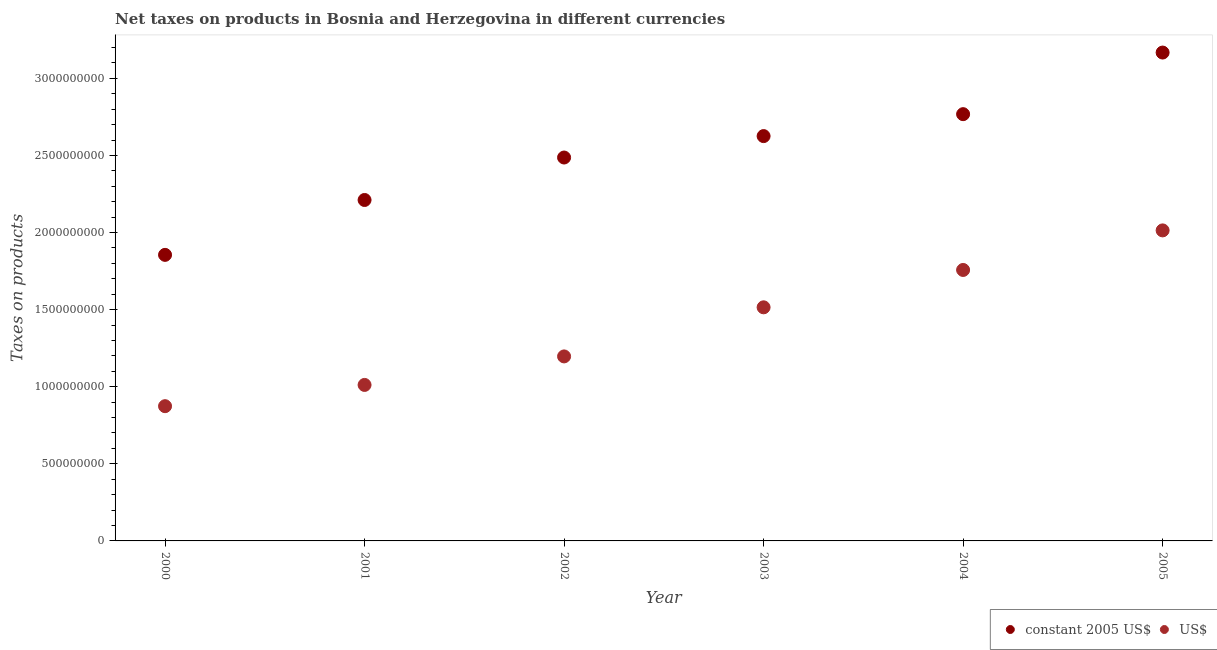What is the net taxes in us$ in 2003?
Make the answer very short. 1.51e+09. Across all years, what is the maximum net taxes in constant 2005 us$?
Offer a terse response. 3.17e+09. Across all years, what is the minimum net taxes in us$?
Keep it short and to the point. 8.74e+08. What is the total net taxes in constant 2005 us$ in the graph?
Your answer should be very brief. 1.51e+1. What is the difference between the net taxes in constant 2005 us$ in 2000 and that in 2001?
Provide a succinct answer. -3.56e+08. What is the difference between the net taxes in us$ in 2004 and the net taxes in constant 2005 us$ in 2005?
Offer a terse response. -1.41e+09. What is the average net taxes in us$ per year?
Ensure brevity in your answer.  1.39e+09. In the year 2005, what is the difference between the net taxes in constant 2005 us$ and net taxes in us$?
Your answer should be very brief. 1.15e+09. In how many years, is the net taxes in constant 2005 us$ greater than 1400000000 units?
Keep it short and to the point. 6. What is the ratio of the net taxes in us$ in 2000 to that in 2005?
Offer a terse response. 0.43. Is the net taxes in constant 2005 us$ in 2000 less than that in 2003?
Ensure brevity in your answer.  Yes. What is the difference between the highest and the second highest net taxes in us$?
Make the answer very short. 2.57e+08. What is the difference between the highest and the lowest net taxes in constant 2005 us$?
Your answer should be very brief. 1.31e+09. How many years are there in the graph?
Ensure brevity in your answer.  6. Are the values on the major ticks of Y-axis written in scientific E-notation?
Ensure brevity in your answer.  No. Does the graph contain grids?
Offer a very short reply. No. How are the legend labels stacked?
Your answer should be very brief. Horizontal. What is the title of the graph?
Ensure brevity in your answer.  Net taxes on products in Bosnia and Herzegovina in different currencies. What is the label or title of the Y-axis?
Make the answer very short. Taxes on products. What is the Taxes on products in constant 2005 US$ in 2000?
Make the answer very short. 1.86e+09. What is the Taxes on products of US$ in 2000?
Your answer should be very brief. 8.74e+08. What is the Taxes on products in constant 2005 US$ in 2001?
Make the answer very short. 2.21e+09. What is the Taxes on products in US$ in 2001?
Offer a very short reply. 1.01e+09. What is the Taxes on products of constant 2005 US$ in 2002?
Keep it short and to the point. 2.49e+09. What is the Taxes on products in US$ in 2002?
Make the answer very short. 1.20e+09. What is the Taxes on products in constant 2005 US$ in 2003?
Ensure brevity in your answer.  2.63e+09. What is the Taxes on products of US$ in 2003?
Offer a terse response. 1.51e+09. What is the Taxes on products in constant 2005 US$ in 2004?
Give a very brief answer. 2.77e+09. What is the Taxes on products of US$ in 2004?
Your answer should be compact. 1.76e+09. What is the Taxes on products of constant 2005 US$ in 2005?
Keep it short and to the point. 3.17e+09. What is the Taxes on products in US$ in 2005?
Your response must be concise. 2.01e+09. Across all years, what is the maximum Taxes on products in constant 2005 US$?
Provide a succinct answer. 3.17e+09. Across all years, what is the maximum Taxes on products in US$?
Offer a very short reply. 2.01e+09. Across all years, what is the minimum Taxes on products in constant 2005 US$?
Offer a terse response. 1.86e+09. Across all years, what is the minimum Taxes on products of US$?
Ensure brevity in your answer.  8.74e+08. What is the total Taxes on products of constant 2005 US$ in the graph?
Give a very brief answer. 1.51e+1. What is the total Taxes on products of US$ in the graph?
Provide a short and direct response. 8.37e+09. What is the difference between the Taxes on products of constant 2005 US$ in 2000 and that in 2001?
Make the answer very short. -3.56e+08. What is the difference between the Taxes on products in US$ in 2000 and that in 2001?
Offer a very short reply. -1.38e+08. What is the difference between the Taxes on products of constant 2005 US$ in 2000 and that in 2002?
Your answer should be compact. -6.31e+08. What is the difference between the Taxes on products in US$ in 2000 and that in 2002?
Your answer should be compact. -3.23e+08. What is the difference between the Taxes on products of constant 2005 US$ in 2000 and that in 2003?
Keep it short and to the point. -7.70e+08. What is the difference between the Taxes on products of US$ in 2000 and that in 2003?
Ensure brevity in your answer.  -6.41e+08. What is the difference between the Taxes on products in constant 2005 US$ in 2000 and that in 2004?
Offer a very short reply. -9.12e+08. What is the difference between the Taxes on products in US$ in 2000 and that in 2004?
Keep it short and to the point. -8.83e+08. What is the difference between the Taxes on products of constant 2005 US$ in 2000 and that in 2005?
Offer a terse response. -1.31e+09. What is the difference between the Taxes on products in US$ in 2000 and that in 2005?
Provide a succinct answer. -1.14e+09. What is the difference between the Taxes on products in constant 2005 US$ in 2001 and that in 2002?
Provide a short and direct response. -2.75e+08. What is the difference between the Taxes on products in US$ in 2001 and that in 2002?
Make the answer very short. -1.85e+08. What is the difference between the Taxes on products of constant 2005 US$ in 2001 and that in 2003?
Your answer should be very brief. -4.14e+08. What is the difference between the Taxes on products of US$ in 2001 and that in 2003?
Make the answer very short. -5.03e+08. What is the difference between the Taxes on products in constant 2005 US$ in 2001 and that in 2004?
Your response must be concise. -5.57e+08. What is the difference between the Taxes on products of US$ in 2001 and that in 2004?
Your answer should be compact. -7.46e+08. What is the difference between the Taxes on products in constant 2005 US$ in 2001 and that in 2005?
Ensure brevity in your answer.  -9.56e+08. What is the difference between the Taxes on products in US$ in 2001 and that in 2005?
Your answer should be compact. -1.00e+09. What is the difference between the Taxes on products of constant 2005 US$ in 2002 and that in 2003?
Offer a terse response. -1.39e+08. What is the difference between the Taxes on products in US$ in 2002 and that in 2003?
Provide a short and direct response. -3.18e+08. What is the difference between the Taxes on products in constant 2005 US$ in 2002 and that in 2004?
Provide a succinct answer. -2.81e+08. What is the difference between the Taxes on products of US$ in 2002 and that in 2004?
Your response must be concise. -5.61e+08. What is the difference between the Taxes on products of constant 2005 US$ in 2002 and that in 2005?
Provide a short and direct response. -6.81e+08. What is the difference between the Taxes on products in US$ in 2002 and that in 2005?
Your response must be concise. -8.17e+08. What is the difference between the Taxes on products in constant 2005 US$ in 2003 and that in 2004?
Your answer should be compact. -1.42e+08. What is the difference between the Taxes on products in US$ in 2003 and that in 2004?
Provide a succinct answer. -2.42e+08. What is the difference between the Taxes on products of constant 2005 US$ in 2003 and that in 2005?
Provide a short and direct response. -5.42e+08. What is the difference between the Taxes on products of US$ in 2003 and that in 2005?
Provide a succinct answer. -4.99e+08. What is the difference between the Taxes on products of constant 2005 US$ in 2004 and that in 2005?
Your response must be concise. -4.00e+08. What is the difference between the Taxes on products in US$ in 2004 and that in 2005?
Your response must be concise. -2.57e+08. What is the difference between the Taxes on products of constant 2005 US$ in 2000 and the Taxes on products of US$ in 2001?
Your response must be concise. 8.43e+08. What is the difference between the Taxes on products in constant 2005 US$ in 2000 and the Taxes on products in US$ in 2002?
Keep it short and to the point. 6.59e+08. What is the difference between the Taxes on products of constant 2005 US$ in 2000 and the Taxes on products of US$ in 2003?
Provide a short and direct response. 3.40e+08. What is the difference between the Taxes on products in constant 2005 US$ in 2000 and the Taxes on products in US$ in 2004?
Keep it short and to the point. 9.79e+07. What is the difference between the Taxes on products of constant 2005 US$ in 2000 and the Taxes on products of US$ in 2005?
Make the answer very short. -1.59e+08. What is the difference between the Taxes on products of constant 2005 US$ in 2001 and the Taxes on products of US$ in 2002?
Offer a very short reply. 1.01e+09. What is the difference between the Taxes on products in constant 2005 US$ in 2001 and the Taxes on products in US$ in 2003?
Your response must be concise. 6.96e+08. What is the difference between the Taxes on products of constant 2005 US$ in 2001 and the Taxes on products of US$ in 2004?
Ensure brevity in your answer.  4.54e+08. What is the difference between the Taxes on products in constant 2005 US$ in 2001 and the Taxes on products in US$ in 2005?
Offer a very short reply. 1.97e+08. What is the difference between the Taxes on products in constant 2005 US$ in 2002 and the Taxes on products in US$ in 2003?
Offer a terse response. 9.71e+08. What is the difference between the Taxes on products of constant 2005 US$ in 2002 and the Taxes on products of US$ in 2004?
Ensure brevity in your answer.  7.29e+08. What is the difference between the Taxes on products in constant 2005 US$ in 2002 and the Taxes on products in US$ in 2005?
Your response must be concise. 4.73e+08. What is the difference between the Taxes on products in constant 2005 US$ in 2003 and the Taxes on products in US$ in 2004?
Ensure brevity in your answer.  8.68e+08. What is the difference between the Taxes on products of constant 2005 US$ in 2003 and the Taxes on products of US$ in 2005?
Give a very brief answer. 6.12e+08. What is the difference between the Taxes on products in constant 2005 US$ in 2004 and the Taxes on products in US$ in 2005?
Provide a succinct answer. 7.54e+08. What is the average Taxes on products of constant 2005 US$ per year?
Ensure brevity in your answer.  2.52e+09. What is the average Taxes on products in US$ per year?
Ensure brevity in your answer.  1.39e+09. In the year 2000, what is the difference between the Taxes on products in constant 2005 US$ and Taxes on products in US$?
Give a very brief answer. 9.81e+08. In the year 2001, what is the difference between the Taxes on products in constant 2005 US$ and Taxes on products in US$?
Keep it short and to the point. 1.20e+09. In the year 2002, what is the difference between the Taxes on products of constant 2005 US$ and Taxes on products of US$?
Your answer should be very brief. 1.29e+09. In the year 2003, what is the difference between the Taxes on products in constant 2005 US$ and Taxes on products in US$?
Provide a succinct answer. 1.11e+09. In the year 2004, what is the difference between the Taxes on products of constant 2005 US$ and Taxes on products of US$?
Your response must be concise. 1.01e+09. In the year 2005, what is the difference between the Taxes on products in constant 2005 US$ and Taxes on products in US$?
Give a very brief answer. 1.15e+09. What is the ratio of the Taxes on products of constant 2005 US$ in 2000 to that in 2001?
Give a very brief answer. 0.84. What is the ratio of the Taxes on products in US$ in 2000 to that in 2001?
Provide a succinct answer. 0.86. What is the ratio of the Taxes on products in constant 2005 US$ in 2000 to that in 2002?
Your response must be concise. 0.75. What is the ratio of the Taxes on products of US$ in 2000 to that in 2002?
Provide a short and direct response. 0.73. What is the ratio of the Taxes on products of constant 2005 US$ in 2000 to that in 2003?
Keep it short and to the point. 0.71. What is the ratio of the Taxes on products in US$ in 2000 to that in 2003?
Your response must be concise. 0.58. What is the ratio of the Taxes on products of constant 2005 US$ in 2000 to that in 2004?
Provide a short and direct response. 0.67. What is the ratio of the Taxes on products in US$ in 2000 to that in 2004?
Keep it short and to the point. 0.5. What is the ratio of the Taxes on products of constant 2005 US$ in 2000 to that in 2005?
Ensure brevity in your answer.  0.59. What is the ratio of the Taxes on products of US$ in 2000 to that in 2005?
Offer a very short reply. 0.43. What is the ratio of the Taxes on products in constant 2005 US$ in 2001 to that in 2002?
Provide a short and direct response. 0.89. What is the ratio of the Taxes on products in US$ in 2001 to that in 2002?
Keep it short and to the point. 0.85. What is the ratio of the Taxes on products of constant 2005 US$ in 2001 to that in 2003?
Make the answer very short. 0.84. What is the ratio of the Taxes on products of US$ in 2001 to that in 2003?
Your answer should be compact. 0.67. What is the ratio of the Taxes on products in constant 2005 US$ in 2001 to that in 2004?
Provide a succinct answer. 0.8. What is the ratio of the Taxes on products of US$ in 2001 to that in 2004?
Give a very brief answer. 0.58. What is the ratio of the Taxes on products of constant 2005 US$ in 2001 to that in 2005?
Your answer should be compact. 0.7. What is the ratio of the Taxes on products of US$ in 2001 to that in 2005?
Provide a short and direct response. 0.5. What is the ratio of the Taxes on products of constant 2005 US$ in 2002 to that in 2003?
Give a very brief answer. 0.95. What is the ratio of the Taxes on products in US$ in 2002 to that in 2003?
Make the answer very short. 0.79. What is the ratio of the Taxes on products of constant 2005 US$ in 2002 to that in 2004?
Provide a succinct answer. 0.9. What is the ratio of the Taxes on products in US$ in 2002 to that in 2004?
Provide a short and direct response. 0.68. What is the ratio of the Taxes on products in constant 2005 US$ in 2002 to that in 2005?
Make the answer very short. 0.79. What is the ratio of the Taxes on products in US$ in 2002 to that in 2005?
Ensure brevity in your answer.  0.59. What is the ratio of the Taxes on products in constant 2005 US$ in 2003 to that in 2004?
Ensure brevity in your answer.  0.95. What is the ratio of the Taxes on products in US$ in 2003 to that in 2004?
Keep it short and to the point. 0.86. What is the ratio of the Taxes on products of constant 2005 US$ in 2003 to that in 2005?
Provide a succinct answer. 0.83. What is the ratio of the Taxes on products in US$ in 2003 to that in 2005?
Your answer should be very brief. 0.75. What is the ratio of the Taxes on products in constant 2005 US$ in 2004 to that in 2005?
Offer a very short reply. 0.87. What is the ratio of the Taxes on products of US$ in 2004 to that in 2005?
Keep it short and to the point. 0.87. What is the difference between the highest and the second highest Taxes on products in constant 2005 US$?
Keep it short and to the point. 4.00e+08. What is the difference between the highest and the second highest Taxes on products in US$?
Offer a very short reply. 2.57e+08. What is the difference between the highest and the lowest Taxes on products of constant 2005 US$?
Your response must be concise. 1.31e+09. What is the difference between the highest and the lowest Taxes on products of US$?
Ensure brevity in your answer.  1.14e+09. 